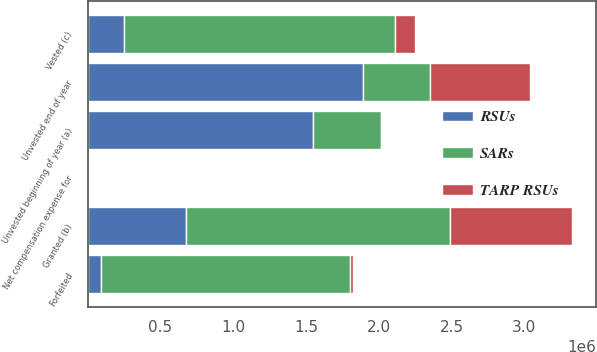<chart> <loc_0><loc_0><loc_500><loc_500><stacked_bar_chart><ecel><fcel>Unvested beginning of year (a)<fcel>Granted (b)<fcel>Vested (c)<fcel>Forfeited<fcel>Unvested end of year<fcel>Net compensation expense for<nl><fcel>SARs<fcel>462311<fcel>1.80984e+06<fcel>1.8648e+06<fcel>1.71153e+06<fcel>462311<fcel>84<nl><fcel>RSUs<fcel>1.54962e+06<fcel>678188<fcel>246434<fcel>91942<fcel>1.88943e+06<fcel>31<nl><fcel>TARP RSUs<fcel>7389<fcel>836355<fcel>139169<fcel>18285<fcel>686290<fcel>17<nl></chart> 